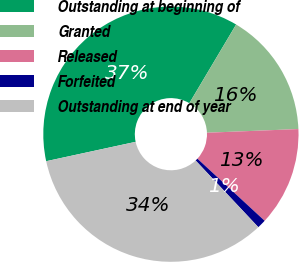Convert chart. <chart><loc_0><loc_0><loc_500><loc_500><pie_chart><fcel>Outstanding at beginning of<fcel>Granted<fcel>Released<fcel>Forfeited<fcel>Outstanding at end of year<nl><fcel>36.93%<fcel>15.82%<fcel>12.51%<fcel>1.12%<fcel>33.61%<nl></chart> 